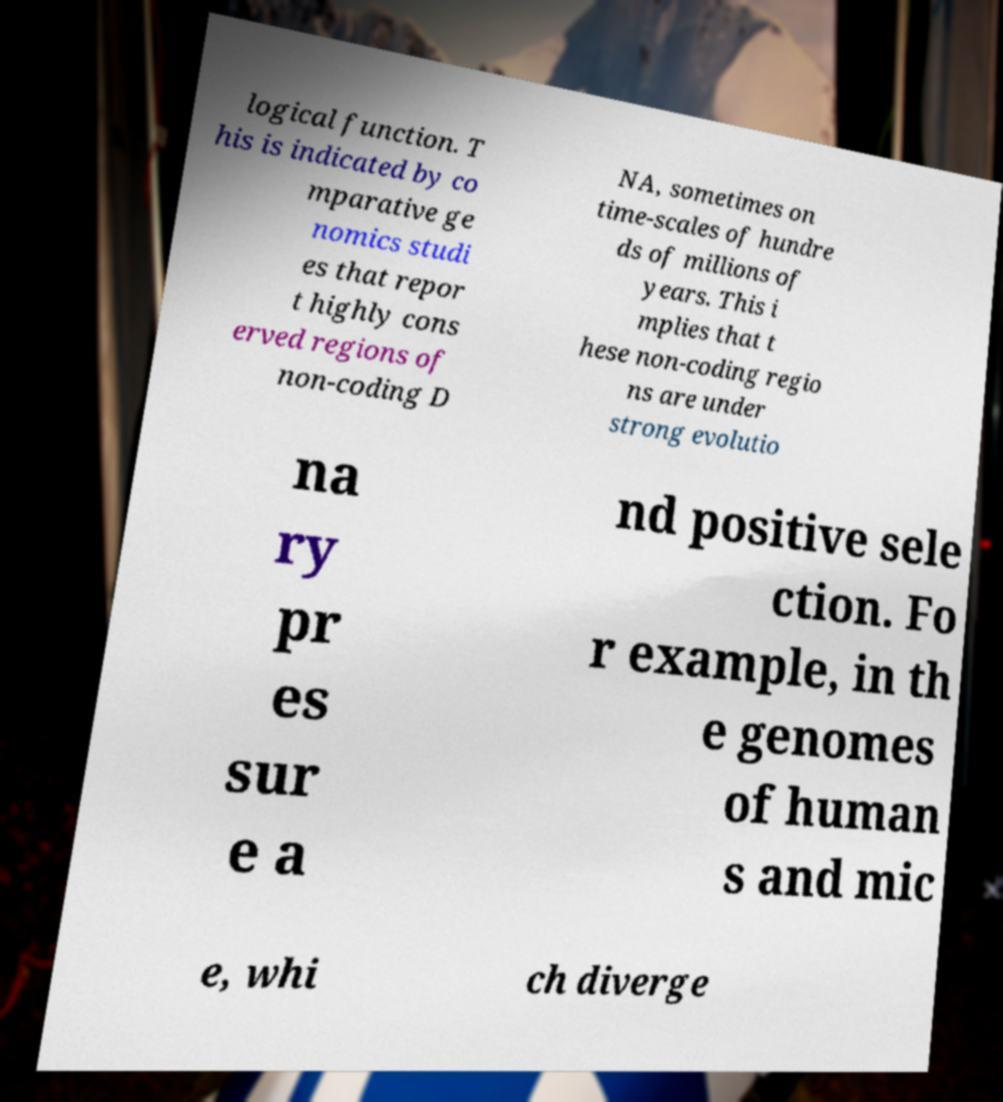Can you read and provide the text displayed in the image?This photo seems to have some interesting text. Can you extract and type it out for me? logical function. T his is indicated by co mparative ge nomics studi es that repor t highly cons erved regions of non-coding D NA, sometimes on time-scales of hundre ds of millions of years. This i mplies that t hese non-coding regio ns are under strong evolutio na ry pr es sur e a nd positive sele ction. Fo r example, in th e genomes of human s and mic e, whi ch diverge 